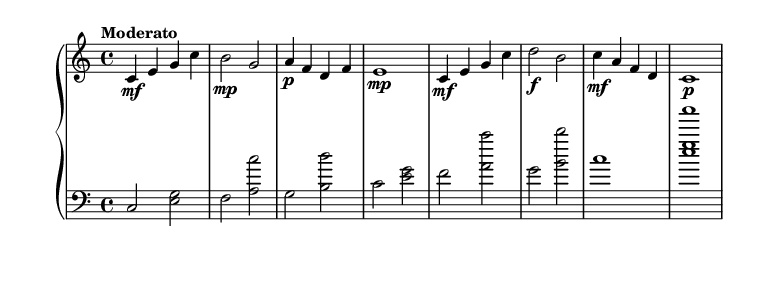What is the key signature of this music? The key signature is C major, which has no sharps or flats.
Answer: C major What is the time signature of this music? The time signature indicated at the beginning is 4/4, which means there are four beats in a measure.
Answer: 4/4 What is the tempo marking for this piece? The tempo marking given is "Moderato", suggesting a moderately fast tempo.
Answer: Moderato Who is the composer of this piece? The composer's name is stated in the header, which identifies Aaron Copland as the composer of "American Frontier".
Answer: Aaron Copland How many measures are in the upper staff? By counting the measures indicated in the upper staff, there are a total of 8 measures present.
Answer: 8 What dynamics are applied to the second measure of the upper staff? The second measure has a dynamic marking of "mp", indicating a moderately soft volume.
Answer: mp What instrument is this sheet music written for? The instrument specified in the header is the Piano, which means it is intended for that instrument.
Answer: Piano 